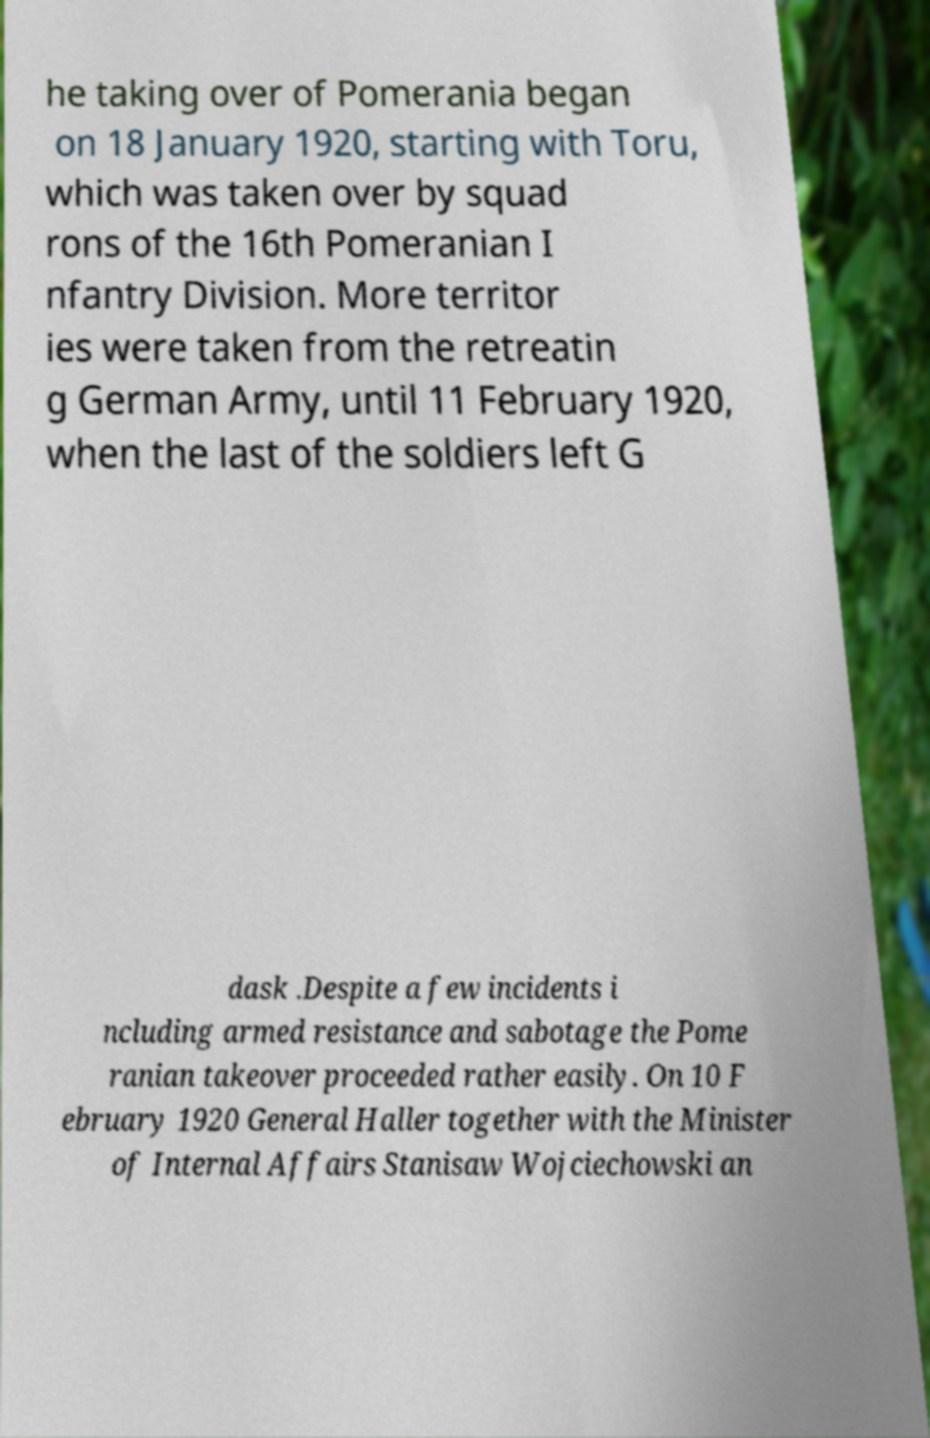Could you extract and type out the text from this image? he taking over of Pomerania began on 18 January 1920, starting with Toru, which was taken over by squad rons of the 16th Pomeranian I nfantry Division. More territor ies were taken from the retreatin g German Army, until 11 February 1920, when the last of the soldiers left G dask .Despite a few incidents i ncluding armed resistance and sabotage the Pome ranian takeover proceeded rather easily. On 10 F ebruary 1920 General Haller together with the Minister of Internal Affairs Stanisaw Wojciechowski an 